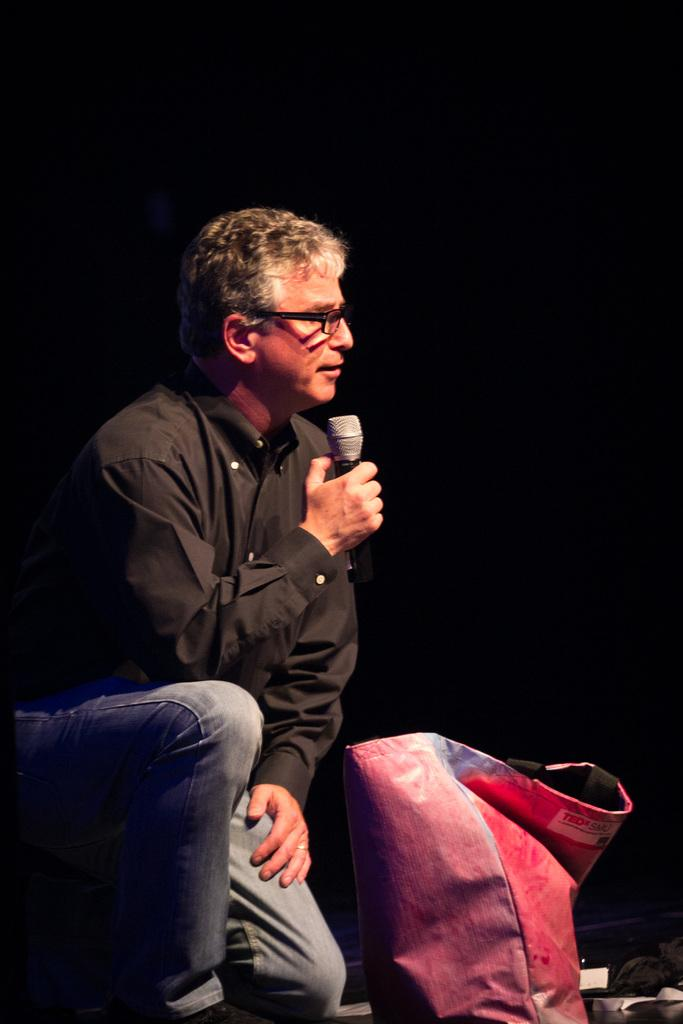Who is present in the image? There is a man in the image. What is the man doing in the image? The man is sitting on the floor and holding a microphone in his hands. What else can be seen in the image? There is a bag in the image. What type of pencil is the man using to draw on the floor in the image? There is no pencil present in the image, and the man is holding a microphone, not drawing on the floor. 